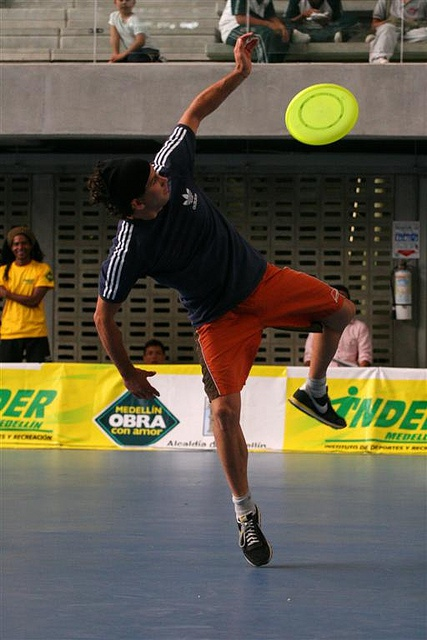Describe the objects in this image and their specific colors. I can see people in gray, black, and maroon tones, people in gray, black, orange, olive, and maroon tones, frisbee in gray, khaki, olive, and yellow tones, people in gray, black, lightgray, and maroon tones, and people in gray, darkgray, and black tones in this image. 